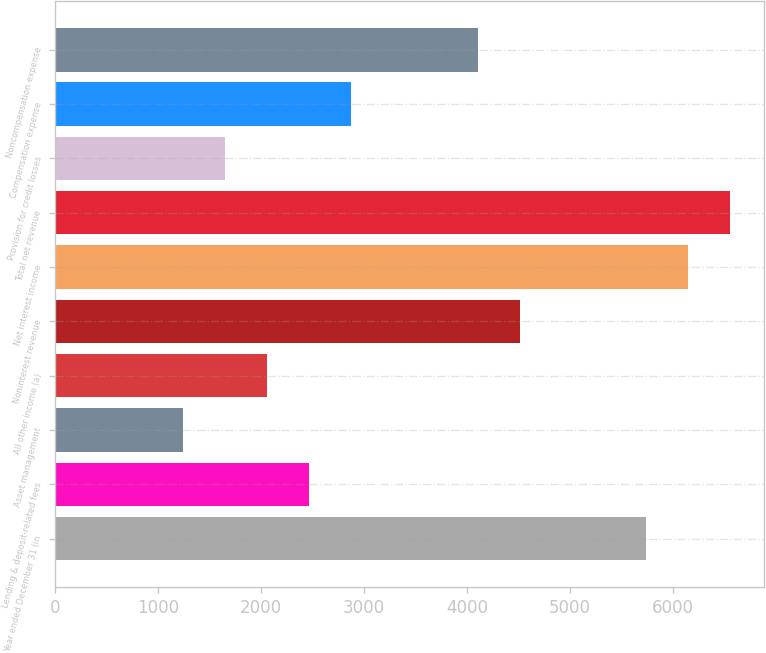Convert chart. <chart><loc_0><loc_0><loc_500><loc_500><bar_chart><fcel>Year ended December 31 (in<fcel>Lending & deposit-related fees<fcel>Asset management<fcel>All other income (a)<fcel>Noninterest revenue<fcel>Net interest income<fcel>Total net revenue<fcel>Provision for credit losses<fcel>Compensation expense<fcel>Noncompensation expense<nl><fcel>5737.4<fcel>2468.6<fcel>1242.8<fcel>2060<fcel>4511.6<fcel>6146<fcel>6554.6<fcel>1651.4<fcel>2877.2<fcel>4103<nl></chart> 